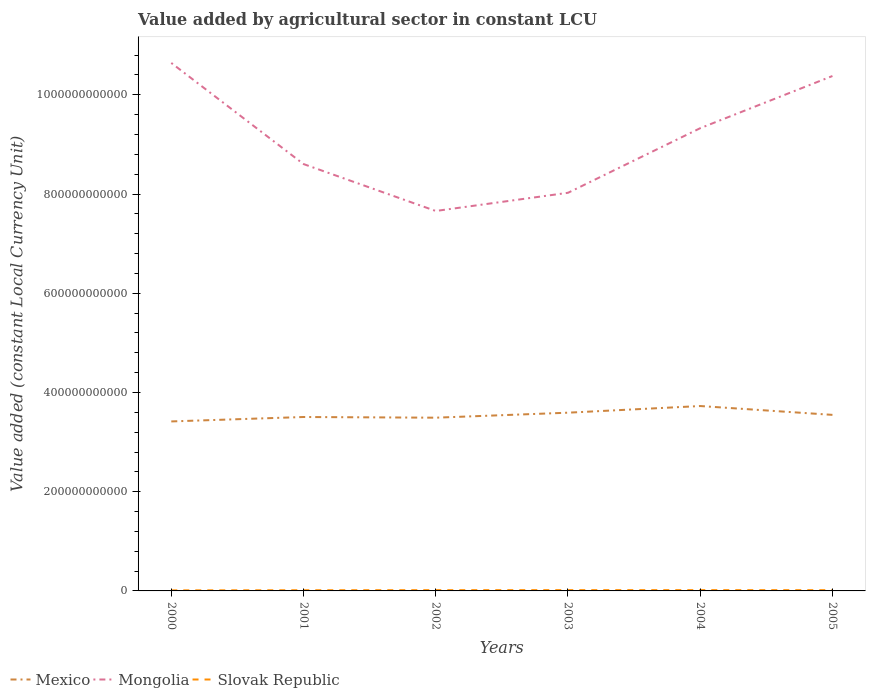Does the line corresponding to Mongolia intersect with the line corresponding to Slovak Republic?
Your response must be concise. No. Is the number of lines equal to the number of legend labels?
Ensure brevity in your answer.  Yes. Across all years, what is the maximum value added by agricultural sector in Mongolia?
Offer a terse response. 7.66e+11. What is the total value added by agricultural sector in Mongolia in the graph?
Your answer should be very brief. -1.30e+11. What is the difference between the highest and the second highest value added by agricultural sector in Mongolia?
Provide a succinct answer. 2.98e+11. How many lines are there?
Provide a succinct answer. 3. How many years are there in the graph?
Provide a short and direct response. 6. What is the difference between two consecutive major ticks on the Y-axis?
Provide a short and direct response. 2.00e+11. Does the graph contain any zero values?
Your answer should be very brief. No. Does the graph contain grids?
Your response must be concise. No. How many legend labels are there?
Keep it short and to the point. 3. What is the title of the graph?
Keep it short and to the point. Value added by agricultural sector in constant LCU. What is the label or title of the Y-axis?
Give a very brief answer. Value added (constant Local Currency Unit). What is the Value added (constant Local Currency Unit) of Mexico in 2000?
Ensure brevity in your answer.  3.42e+11. What is the Value added (constant Local Currency Unit) of Mongolia in 2000?
Give a very brief answer. 1.06e+12. What is the Value added (constant Local Currency Unit) in Slovak Republic in 2000?
Make the answer very short. 1.14e+09. What is the Value added (constant Local Currency Unit) of Mexico in 2001?
Your answer should be compact. 3.51e+11. What is the Value added (constant Local Currency Unit) in Mongolia in 2001?
Provide a succinct answer. 8.60e+11. What is the Value added (constant Local Currency Unit) of Slovak Republic in 2001?
Provide a short and direct response. 1.38e+09. What is the Value added (constant Local Currency Unit) of Mexico in 2002?
Your answer should be compact. 3.49e+11. What is the Value added (constant Local Currency Unit) of Mongolia in 2002?
Your answer should be compact. 7.66e+11. What is the Value added (constant Local Currency Unit) of Slovak Republic in 2002?
Give a very brief answer. 1.55e+09. What is the Value added (constant Local Currency Unit) of Mexico in 2003?
Ensure brevity in your answer.  3.59e+11. What is the Value added (constant Local Currency Unit) in Mongolia in 2003?
Provide a short and direct response. 8.02e+11. What is the Value added (constant Local Currency Unit) in Slovak Republic in 2003?
Keep it short and to the point. 1.61e+09. What is the Value added (constant Local Currency Unit) in Mexico in 2004?
Provide a short and direct response. 3.73e+11. What is the Value added (constant Local Currency Unit) in Mongolia in 2004?
Make the answer very short. 9.33e+11. What is the Value added (constant Local Currency Unit) in Slovak Republic in 2004?
Your response must be concise. 1.60e+09. What is the Value added (constant Local Currency Unit) in Mexico in 2005?
Offer a very short reply. 3.55e+11. What is the Value added (constant Local Currency Unit) of Mongolia in 2005?
Keep it short and to the point. 1.04e+12. What is the Value added (constant Local Currency Unit) in Slovak Republic in 2005?
Your answer should be very brief. 1.53e+09. Across all years, what is the maximum Value added (constant Local Currency Unit) in Mexico?
Offer a very short reply. 3.73e+11. Across all years, what is the maximum Value added (constant Local Currency Unit) in Mongolia?
Your response must be concise. 1.06e+12. Across all years, what is the maximum Value added (constant Local Currency Unit) in Slovak Republic?
Provide a succinct answer. 1.61e+09. Across all years, what is the minimum Value added (constant Local Currency Unit) in Mexico?
Give a very brief answer. 3.42e+11. Across all years, what is the minimum Value added (constant Local Currency Unit) of Mongolia?
Provide a short and direct response. 7.66e+11. Across all years, what is the minimum Value added (constant Local Currency Unit) in Slovak Republic?
Make the answer very short. 1.14e+09. What is the total Value added (constant Local Currency Unit) in Mexico in the graph?
Offer a very short reply. 2.13e+12. What is the total Value added (constant Local Currency Unit) of Mongolia in the graph?
Provide a short and direct response. 5.46e+12. What is the total Value added (constant Local Currency Unit) in Slovak Republic in the graph?
Make the answer very short. 8.81e+09. What is the difference between the Value added (constant Local Currency Unit) of Mexico in 2000 and that in 2001?
Provide a short and direct response. -8.93e+09. What is the difference between the Value added (constant Local Currency Unit) in Mongolia in 2000 and that in 2001?
Make the answer very short. 2.04e+11. What is the difference between the Value added (constant Local Currency Unit) of Slovak Republic in 2000 and that in 2001?
Keep it short and to the point. -2.46e+08. What is the difference between the Value added (constant Local Currency Unit) of Mexico in 2000 and that in 2002?
Provide a short and direct response. -7.54e+09. What is the difference between the Value added (constant Local Currency Unit) in Mongolia in 2000 and that in 2002?
Your response must be concise. 2.98e+11. What is the difference between the Value added (constant Local Currency Unit) of Slovak Republic in 2000 and that in 2002?
Your answer should be compact. -4.09e+08. What is the difference between the Value added (constant Local Currency Unit) of Mexico in 2000 and that in 2003?
Give a very brief answer. -1.76e+1. What is the difference between the Value added (constant Local Currency Unit) in Mongolia in 2000 and that in 2003?
Your response must be concise. 2.62e+11. What is the difference between the Value added (constant Local Currency Unit) in Slovak Republic in 2000 and that in 2003?
Keep it short and to the point. -4.75e+08. What is the difference between the Value added (constant Local Currency Unit) of Mexico in 2000 and that in 2004?
Keep it short and to the point. -3.10e+1. What is the difference between the Value added (constant Local Currency Unit) in Mongolia in 2000 and that in 2004?
Offer a very short reply. 1.31e+11. What is the difference between the Value added (constant Local Currency Unit) in Slovak Republic in 2000 and that in 2004?
Give a very brief answer. -4.62e+08. What is the difference between the Value added (constant Local Currency Unit) of Mexico in 2000 and that in 2005?
Provide a succinct answer. -1.32e+1. What is the difference between the Value added (constant Local Currency Unit) of Mongolia in 2000 and that in 2005?
Keep it short and to the point. 2.63e+1. What is the difference between the Value added (constant Local Currency Unit) of Slovak Republic in 2000 and that in 2005?
Provide a succinct answer. -3.98e+08. What is the difference between the Value added (constant Local Currency Unit) in Mexico in 2001 and that in 2002?
Provide a succinct answer. 1.39e+09. What is the difference between the Value added (constant Local Currency Unit) of Mongolia in 2001 and that in 2002?
Your answer should be compact. 9.46e+1. What is the difference between the Value added (constant Local Currency Unit) of Slovak Republic in 2001 and that in 2002?
Your answer should be compact. -1.63e+08. What is the difference between the Value added (constant Local Currency Unit) of Mexico in 2001 and that in 2003?
Provide a short and direct response. -8.68e+09. What is the difference between the Value added (constant Local Currency Unit) in Mongolia in 2001 and that in 2003?
Give a very brief answer. 5.79e+1. What is the difference between the Value added (constant Local Currency Unit) in Slovak Republic in 2001 and that in 2003?
Your response must be concise. -2.29e+08. What is the difference between the Value added (constant Local Currency Unit) in Mexico in 2001 and that in 2004?
Make the answer very short. -2.21e+1. What is the difference between the Value added (constant Local Currency Unit) in Mongolia in 2001 and that in 2004?
Your response must be concise. -7.23e+1. What is the difference between the Value added (constant Local Currency Unit) in Slovak Republic in 2001 and that in 2004?
Ensure brevity in your answer.  -2.16e+08. What is the difference between the Value added (constant Local Currency Unit) in Mexico in 2001 and that in 2005?
Keep it short and to the point. -4.29e+09. What is the difference between the Value added (constant Local Currency Unit) of Mongolia in 2001 and that in 2005?
Offer a very short reply. -1.77e+11. What is the difference between the Value added (constant Local Currency Unit) of Slovak Republic in 2001 and that in 2005?
Your response must be concise. -1.52e+08. What is the difference between the Value added (constant Local Currency Unit) of Mexico in 2002 and that in 2003?
Your answer should be very brief. -1.01e+1. What is the difference between the Value added (constant Local Currency Unit) in Mongolia in 2002 and that in 2003?
Ensure brevity in your answer.  -3.66e+1. What is the difference between the Value added (constant Local Currency Unit) of Slovak Republic in 2002 and that in 2003?
Provide a succinct answer. -6.56e+07. What is the difference between the Value added (constant Local Currency Unit) of Mexico in 2002 and that in 2004?
Your answer should be compact. -2.35e+1. What is the difference between the Value added (constant Local Currency Unit) of Mongolia in 2002 and that in 2004?
Ensure brevity in your answer.  -1.67e+11. What is the difference between the Value added (constant Local Currency Unit) in Slovak Republic in 2002 and that in 2004?
Provide a short and direct response. -5.32e+07. What is the difference between the Value added (constant Local Currency Unit) in Mexico in 2002 and that in 2005?
Make the answer very short. -5.68e+09. What is the difference between the Value added (constant Local Currency Unit) in Mongolia in 2002 and that in 2005?
Give a very brief answer. -2.72e+11. What is the difference between the Value added (constant Local Currency Unit) in Slovak Republic in 2002 and that in 2005?
Keep it short and to the point. 1.12e+07. What is the difference between the Value added (constant Local Currency Unit) of Mexico in 2003 and that in 2004?
Your answer should be compact. -1.34e+1. What is the difference between the Value added (constant Local Currency Unit) of Mongolia in 2003 and that in 2004?
Provide a short and direct response. -1.30e+11. What is the difference between the Value added (constant Local Currency Unit) of Slovak Republic in 2003 and that in 2004?
Offer a terse response. 1.24e+07. What is the difference between the Value added (constant Local Currency Unit) in Mexico in 2003 and that in 2005?
Provide a short and direct response. 4.39e+09. What is the difference between the Value added (constant Local Currency Unit) in Mongolia in 2003 and that in 2005?
Your answer should be compact. -2.35e+11. What is the difference between the Value added (constant Local Currency Unit) of Slovak Republic in 2003 and that in 2005?
Offer a terse response. 7.68e+07. What is the difference between the Value added (constant Local Currency Unit) in Mexico in 2004 and that in 2005?
Your answer should be very brief. 1.78e+1. What is the difference between the Value added (constant Local Currency Unit) of Mongolia in 2004 and that in 2005?
Make the answer very short. -1.05e+11. What is the difference between the Value added (constant Local Currency Unit) in Slovak Republic in 2004 and that in 2005?
Make the answer very short. 6.44e+07. What is the difference between the Value added (constant Local Currency Unit) in Mexico in 2000 and the Value added (constant Local Currency Unit) in Mongolia in 2001?
Provide a succinct answer. -5.19e+11. What is the difference between the Value added (constant Local Currency Unit) of Mexico in 2000 and the Value added (constant Local Currency Unit) of Slovak Republic in 2001?
Provide a short and direct response. 3.40e+11. What is the difference between the Value added (constant Local Currency Unit) of Mongolia in 2000 and the Value added (constant Local Currency Unit) of Slovak Republic in 2001?
Offer a very short reply. 1.06e+12. What is the difference between the Value added (constant Local Currency Unit) in Mexico in 2000 and the Value added (constant Local Currency Unit) in Mongolia in 2002?
Your response must be concise. -4.24e+11. What is the difference between the Value added (constant Local Currency Unit) in Mexico in 2000 and the Value added (constant Local Currency Unit) in Slovak Republic in 2002?
Keep it short and to the point. 3.40e+11. What is the difference between the Value added (constant Local Currency Unit) of Mongolia in 2000 and the Value added (constant Local Currency Unit) of Slovak Republic in 2002?
Ensure brevity in your answer.  1.06e+12. What is the difference between the Value added (constant Local Currency Unit) in Mexico in 2000 and the Value added (constant Local Currency Unit) in Mongolia in 2003?
Offer a very short reply. -4.61e+11. What is the difference between the Value added (constant Local Currency Unit) of Mexico in 2000 and the Value added (constant Local Currency Unit) of Slovak Republic in 2003?
Make the answer very short. 3.40e+11. What is the difference between the Value added (constant Local Currency Unit) of Mongolia in 2000 and the Value added (constant Local Currency Unit) of Slovak Republic in 2003?
Provide a short and direct response. 1.06e+12. What is the difference between the Value added (constant Local Currency Unit) of Mexico in 2000 and the Value added (constant Local Currency Unit) of Mongolia in 2004?
Your answer should be very brief. -5.91e+11. What is the difference between the Value added (constant Local Currency Unit) of Mexico in 2000 and the Value added (constant Local Currency Unit) of Slovak Republic in 2004?
Make the answer very short. 3.40e+11. What is the difference between the Value added (constant Local Currency Unit) in Mongolia in 2000 and the Value added (constant Local Currency Unit) in Slovak Republic in 2004?
Make the answer very short. 1.06e+12. What is the difference between the Value added (constant Local Currency Unit) in Mexico in 2000 and the Value added (constant Local Currency Unit) in Mongolia in 2005?
Provide a short and direct response. -6.96e+11. What is the difference between the Value added (constant Local Currency Unit) of Mexico in 2000 and the Value added (constant Local Currency Unit) of Slovak Republic in 2005?
Your answer should be very brief. 3.40e+11. What is the difference between the Value added (constant Local Currency Unit) in Mongolia in 2000 and the Value added (constant Local Currency Unit) in Slovak Republic in 2005?
Your answer should be compact. 1.06e+12. What is the difference between the Value added (constant Local Currency Unit) of Mexico in 2001 and the Value added (constant Local Currency Unit) of Mongolia in 2002?
Your answer should be compact. -4.15e+11. What is the difference between the Value added (constant Local Currency Unit) of Mexico in 2001 and the Value added (constant Local Currency Unit) of Slovak Republic in 2002?
Provide a succinct answer. 3.49e+11. What is the difference between the Value added (constant Local Currency Unit) in Mongolia in 2001 and the Value added (constant Local Currency Unit) in Slovak Republic in 2002?
Give a very brief answer. 8.59e+11. What is the difference between the Value added (constant Local Currency Unit) of Mexico in 2001 and the Value added (constant Local Currency Unit) of Mongolia in 2003?
Offer a terse response. -4.52e+11. What is the difference between the Value added (constant Local Currency Unit) in Mexico in 2001 and the Value added (constant Local Currency Unit) in Slovak Republic in 2003?
Ensure brevity in your answer.  3.49e+11. What is the difference between the Value added (constant Local Currency Unit) of Mongolia in 2001 and the Value added (constant Local Currency Unit) of Slovak Republic in 2003?
Your answer should be very brief. 8.59e+11. What is the difference between the Value added (constant Local Currency Unit) of Mexico in 2001 and the Value added (constant Local Currency Unit) of Mongolia in 2004?
Provide a succinct answer. -5.82e+11. What is the difference between the Value added (constant Local Currency Unit) of Mexico in 2001 and the Value added (constant Local Currency Unit) of Slovak Republic in 2004?
Make the answer very short. 3.49e+11. What is the difference between the Value added (constant Local Currency Unit) in Mongolia in 2001 and the Value added (constant Local Currency Unit) in Slovak Republic in 2004?
Give a very brief answer. 8.59e+11. What is the difference between the Value added (constant Local Currency Unit) in Mexico in 2001 and the Value added (constant Local Currency Unit) in Mongolia in 2005?
Provide a succinct answer. -6.87e+11. What is the difference between the Value added (constant Local Currency Unit) of Mexico in 2001 and the Value added (constant Local Currency Unit) of Slovak Republic in 2005?
Ensure brevity in your answer.  3.49e+11. What is the difference between the Value added (constant Local Currency Unit) of Mongolia in 2001 and the Value added (constant Local Currency Unit) of Slovak Republic in 2005?
Your answer should be very brief. 8.59e+11. What is the difference between the Value added (constant Local Currency Unit) of Mexico in 2002 and the Value added (constant Local Currency Unit) of Mongolia in 2003?
Provide a short and direct response. -4.53e+11. What is the difference between the Value added (constant Local Currency Unit) of Mexico in 2002 and the Value added (constant Local Currency Unit) of Slovak Republic in 2003?
Provide a succinct answer. 3.48e+11. What is the difference between the Value added (constant Local Currency Unit) of Mongolia in 2002 and the Value added (constant Local Currency Unit) of Slovak Republic in 2003?
Provide a succinct answer. 7.64e+11. What is the difference between the Value added (constant Local Currency Unit) of Mexico in 2002 and the Value added (constant Local Currency Unit) of Mongolia in 2004?
Provide a succinct answer. -5.83e+11. What is the difference between the Value added (constant Local Currency Unit) of Mexico in 2002 and the Value added (constant Local Currency Unit) of Slovak Republic in 2004?
Give a very brief answer. 3.48e+11. What is the difference between the Value added (constant Local Currency Unit) of Mongolia in 2002 and the Value added (constant Local Currency Unit) of Slovak Republic in 2004?
Your answer should be compact. 7.64e+11. What is the difference between the Value added (constant Local Currency Unit) in Mexico in 2002 and the Value added (constant Local Currency Unit) in Mongolia in 2005?
Keep it short and to the point. -6.89e+11. What is the difference between the Value added (constant Local Currency Unit) of Mexico in 2002 and the Value added (constant Local Currency Unit) of Slovak Republic in 2005?
Provide a short and direct response. 3.48e+11. What is the difference between the Value added (constant Local Currency Unit) of Mongolia in 2002 and the Value added (constant Local Currency Unit) of Slovak Republic in 2005?
Your response must be concise. 7.64e+11. What is the difference between the Value added (constant Local Currency Unit) of Mexico in 2003 and the Value added (constant Local Currency Unit) of Mongolia in 2004?
Keep it short and to the point. -5.73e+11. What is the difference between the Value added (constant Local Currency Unit) in Mexico in 2003 and the Value added (constant Local Currency Unit) in Slovak Republic in 2004?
Your answer should be very brief. 3.58e+11. What is the difference between the Value added (constant Local Currency Unit) of Mongolia in 2003 and the Value added (constant Local Currency Unit) of Slovak Republic in 2004?
Your answer should be very brief. 8.01e+11. What is the difference between the Value added (constant Local Currency Unit) in Mexico in 2003 and the Value added (constant Local Currency Unit) in Mongolia in 2005?
Ensure brevity in your answer.  -6.79e+11. What is the difference between the Value added (constant Local Currency Unit) in Mexico in 2003 and the Value added (constant Local Currency Unit) in Slovak Republic in 2005?
Keep it short and to the point. 3.58e+11. What is the difference between the Value added (constant Local Currency Unit) of Mongolia in 2003 and the Value added (constant Local Currency Unit) of Slovak Republic in 2005?
Offer a very short reply. 8.01e+11. What is the difference between the Value added (constant Local Currency Unit) in Mexico in 2004 and the Value added (constant Local Currency Unit) in Mongolia in 2005?
Your answer should be compact. -6.65e+11. What is the difference between the Value added (constant Local Currency Unit) of Mexico in 2004 and the Value added (constant Local Currency Unit) of Slovak Republic in 2005?
Offer a very short reply. 3.71e+11. What is the difference between the Value added (constant Local Currency Unit) of Mongolia in 2004 and the Value added (constant Local Currency Unit) of Slovak Republic in 2005?
Give a very brief answer. 9.31e+11. What is the average Value added (constant Local Currency Unit) in Mexico per year?
Your answer should be very brief. 3.55e+11. What is the average Value added (constant Local Currency Unit) of Mongolia per year?
Provide a short and direct response. 9.11e+11. What is the average Value added (constant Local Currency Unit) of Slovak Republic per year?
Your answer should be very brief. 1.47e+09. In the year 2000, what is the difference between the Value added (constant Local Currency Unit) in Mexico and Value added (constant Local Currency Unit) in Mongolia?
Give a very brief answer. -7.23e+11. In the year 2000, what is the difference between the Value added (constant Local Currency Unit) in Mexico and Value added (constant Local Currency Unit) in Slovak Republic?
Provide a short and direct response. 3.40e+11. In the year 2000, what is the difference between the Value added (constant Local Currency Unit) in Mongolia and Value added (constant Local Currency Unit) in Slovak Republic?
Ensure brevity in your answer.  1.06e+12. In the year 2001, what is the difference between the Value added (constant Local Currency Unit) of Mexico and Value added (constant Local Currency Unit) of Mongolia?
Your response must be concise. -5.10e+11. In the year 2001, what is the difference between the Value added (constant Local Currency Unit) of Mexico and Value added (constant Local Currency Unit) of Slovak Republic?
Make the answer very short. 3.49e+11. In the year 2001, what is the difference between the Value added (constant Local Currency Unit) in Mongolia and Value added (constant Local Currency Unit) in Slovak Republic?
Your response must be concise. 8.59e+11. In the year 2002, what is the difference between the Value added (constant Local Currency Unit) of Mexico and Value added (constant Local Currency Unit) of Mongolia?
Give a very brief answer. -4.17e+11. In the year 2002, what is the difference between the Value added (constant Local Currency Unit) in Mexico and Value added (constant Local Currency Unit) in Slovak Republic?
Offer a very short reply. 3.48e+11. In the year 2002, what is the difference between the Value added (constant Local Currency Unit) in Mongolia and Value added (constant Local Currency Unit) in Slovak Republic?
Offer a terse response. 7.64e+11. In the year 2003, what is the difference between the Value added (constant Local Currency Unit) of Mexico and Value added (constant Local Currency Unit) of Mongolia?
Your response must be concise. -4.43e+11. In the year 2003, what is the difference between the Value added (constant Local Currency Unit) in Mexico and Value added (constant Local Currency Unit) in Slovak Republic?
Keep it short and to the point. 3.58e+11. In the year 2003, what is the difference between the Value added (constant Local Currency Unit) of Mongolia and Value added (constant Local Currency Unit) of Slovak Republic?
Your response must be concise. 8.01e+11. In the year 2004, what is the difference between the Value added (constant Local Currency Unit) of Mexico and Value added (constant Local Currency Unit) of Mongolia?
Provide a succinct answer. -5.60e+11. In the year 2004, what is the difference between the Value added (constant Local Currency Unit) in Mexico and Value added (constant Local Currency Unit) in Slovak Republic?
Offer a very short reply. 3.71e+11. In the year 2004, what is the difference between the Value added (constant Local Currency Unit) of Mongolia and Value added (constant Local Currency Unit) of Slovak Republic?
Keep it short and to the point. 9.31e+11. In the year 2005, what is the difference between the Value added (constant Local Currency Unit) of Mexico and Value added (constant Local Currency Unit) of Mongolia?
Ensure brevity in your answer.  -6.83e+11. In the year 2005, what is the difference between the Value added (constant Local Currency Unit) in Mexico and Value added (constant Local Currency Unit) in Slovak Republic?
Your response must be concise. 3.53e+11. In the year 2005, what is the difference between the Value added (constant Local Currency Unit) of Mongolia and Value added (constant Local Currency Unit) of Slovak Republic?
Your response must be concise. 1.04e+12. What is the ratio of the Value added (constant Local Currency Unit) in Mexico in 2000 to that in 2001?
Give a very brief answer. 0.97. What is the ratio of the Value added (constant Local Currency Unit) of Mongolia in 2000 to that in 2001?
Keep it short and to the point. 1.24. What is the ratio of the Value added (constant Local Currency Unit) in Slovak Republic in 2000 to that in 2001?
Ensure brevity in your answer.  0.82. What is the ratio of the Value added (constant Local Currency Unit) of Mexico in 2000 to that in 2002?
Make the answer very short. 0.98. What is the ratio of the Value added (constant Local Currency Unit) of Mongolia in 2000 to that in 2002?
Offer a terse response. 1.39. What is the ratio of the Value added (constant Local Currency Unit) of Slovak Republic in 2000 to that in 2002?
Your answer should be compact. 0.74. What is the ratio of the Value added (constant Local Currency Unit) in Mexico in 2000 to that in 2003?
Keep it short and to the point. 0.95. What is the ratio of the Value added (constant Local Currency Unit) of Mongolia in 2000 to that in 2003?
Keep it short and to the point. 1.33. What is the ratio of the Value added (constant Local Currency Unit) of Slovak Republic in 2000 to that in 2003?
Ensure brevity in your answer.  0.71. What is the ratio of the Value added (constant Local Currency Unit) in Mexico in 2000 to that in 2004?
Keep it short and to the point. 0.92. What is the ratio of the Value added (constant Local Currency Unit) of Mongolia in 2000 to that in 2004?
Keep it short and to the point. 1.14. What is the ratio of the Value added (constant Local Currency Unit) of Slovak Republic in 2000 to that in 2004?
Offer a terse response. 0.71. What is the ratio of the Value added (constant Local Currency Unit) in Mexico in 2000 to that in 2005?
Offer a very short reply. 0.96. What is the ratio of the Value added (constant Local Currency Unit) in Mongolia in 2000 to that in 2005?
Ensure brevity in your answer.  1.03. What is the ratio of the Value added (constant Local Currency Unit) of Slovak Republic in 2000 to that in 2005?
Your answer should be very brief. 0.74. What is the ratio of the Value added (constant Local Currency Unit) of Mexico in 2001 to that in 2002?
Offer a terse response. 1. What is the ratio of the Value added (constant Local Currency Unit) in Mongolia in 2001 to that in 2002?
Your answer should be compact. 1.12. What is the ratio of the Value added (constant Local Currency Unit) in Slovak Republic in 2001 to that in 2002?
Make the answer very short. 0.89. What is the ratio of the Value added (constant Local Currency Unit) of Mexico in 2001 to that in 2003?
Offer a terse response. 0.98. What is the ratio of the Value added (constant Local Currency Unit) of Mongolia in 2001 to that in 2003?
Your answer should be compact. 1.07. What is the ratio of the Value added (constant Local Currency Unit) in Slovak Republic in 2001 to that in 2003?
Provide a short and direct response. 0.86. What is the ratio of the Value added (constant Local Currency Unit) of Mexico in 2001 to that in 2004?
Your answer should be very brief. 0.94. What is the ratio of the Value added (constant Local Currency Unit) in Mongolia in 2001 to that in 2004?
Offer a terse response. 0.92. What is the ratio of the Value added (constant Local Currency Unit) of Slovak Republic in 2001 to that in 2004?
Give a very brief answer. 0.86. What is the ratio of the Value added (constant Local Currency Unit) in Mexico in 2001 to that in 2005?
Offer a terse response. 0.99. What is the ratio of the Value added (constant Local Currency Unit) in Mongolia in 2001 to that in 2005?
Provide a short and direct response. 0.83. What is the ratio of the Value added (constant Local Currency Unit) of Slovak Republic in 2001 to that in 2005?
Provide a succinct answer. 0.9. What is the ratio of the Value added (constant Local Currency Unit) of Mongolia in 2002 to that in 2003?
Keep it short and to the point. 0.95. What is the ratio of the Value added (constant Local Currency Unit) in Slovak Republic in 2002 to that in 2003?
Your answer should be compact. 0.96. What is the ratio of the Value added (constant Local Currency Unit) in Mexico in 2002 to that in 2004?
Keep it short and to the point. 0.94. What is the ratio of the Value added (constant Local Currency Unit) of Mongolia in 2002 to that in 2004?
Your answer should be very brief. 0.82. What is the ratio of the Value added (constant Local Currency Unit) of Slovak Republic in 2002 to that in 2004?
Ensure brevity in your answer.  0.97. What is the ratio of the Value added (constant Local Currency Unit) in Mongolia in 2002 to that in 2005?
Make the answer very short. 0.74. What is the ratio of the Value added (constant Local Currency Unit) in Slovak Republic in 2002 to that in 2005?
Your response must be concise. 1.01. What is the ratio of the Value added (constant Local Currency Unit) of Mongolia in 2003 to that in 2004?
Keep it short and to the point. 0.86. What is the ratio of the Value added (constant Local Currency Unit) in Slovak Republic in 2003 to that in 2004?
Offer a very short reply. 1.01. What is the ratio of the Value added (constant Local Currency Unit) of Mexico in 2003 to that in 2005?
Provide a succinct answer. 1.01. What is the ratio of the Value added (constant Local Currency Unit) of Mongolia in 2003 to that in 2005?
Offer a terse response. 0.77. What is the ratio of the Value added (constant Local Currency Unit) in Slovak Republic in 2003 to that in 2005?
Keep it short and to the point. 1.05. What is the ratio of the Value added (constant Local Currency Unit) in Mexico in 2004 to that in 2005?
Give a very brief answer. 1.05. What is the ratio of the Value added (constant Local Currency Unit) of Mongolia in 2004 to that in 2005?
Offer a terse response. 0.9. What is the ratio of the Value added (constant Local Currency Unit) of Slovak Republic in 2004 to that in 2005?
Make the answer very short. 1.04. What is the difference between the highest and the second highest Value added (constant Local Currency Unit) of Mexico?
Provide a succinct answer. 1.34e+1. What is the difference between the highest and the second highest Value added (constant Local Currency Unit) of Mongolia?
Provide a short and direct response. 2.63e+1. What is the difference between the highest and the second highest Value added (constant Local Currency Unit) in Slovak Republic?
Make the answer very short. 1.24e+07. What is the difference between the highest and the lowest Value added (constant Local Currency Unit) in Mexico?
Your response must be concise. 3.10e+1. What is the difference between the highest and the lowest Value added (constant Local Currency Unit) in Mongolia?
Ensure brevity in your answer.  2.98e+11. What is the difference between the highest and the lowest Value added (constant Local Currency Unit) of Slovak Republic?
Your answer should be very brief. 4.75e+08. 